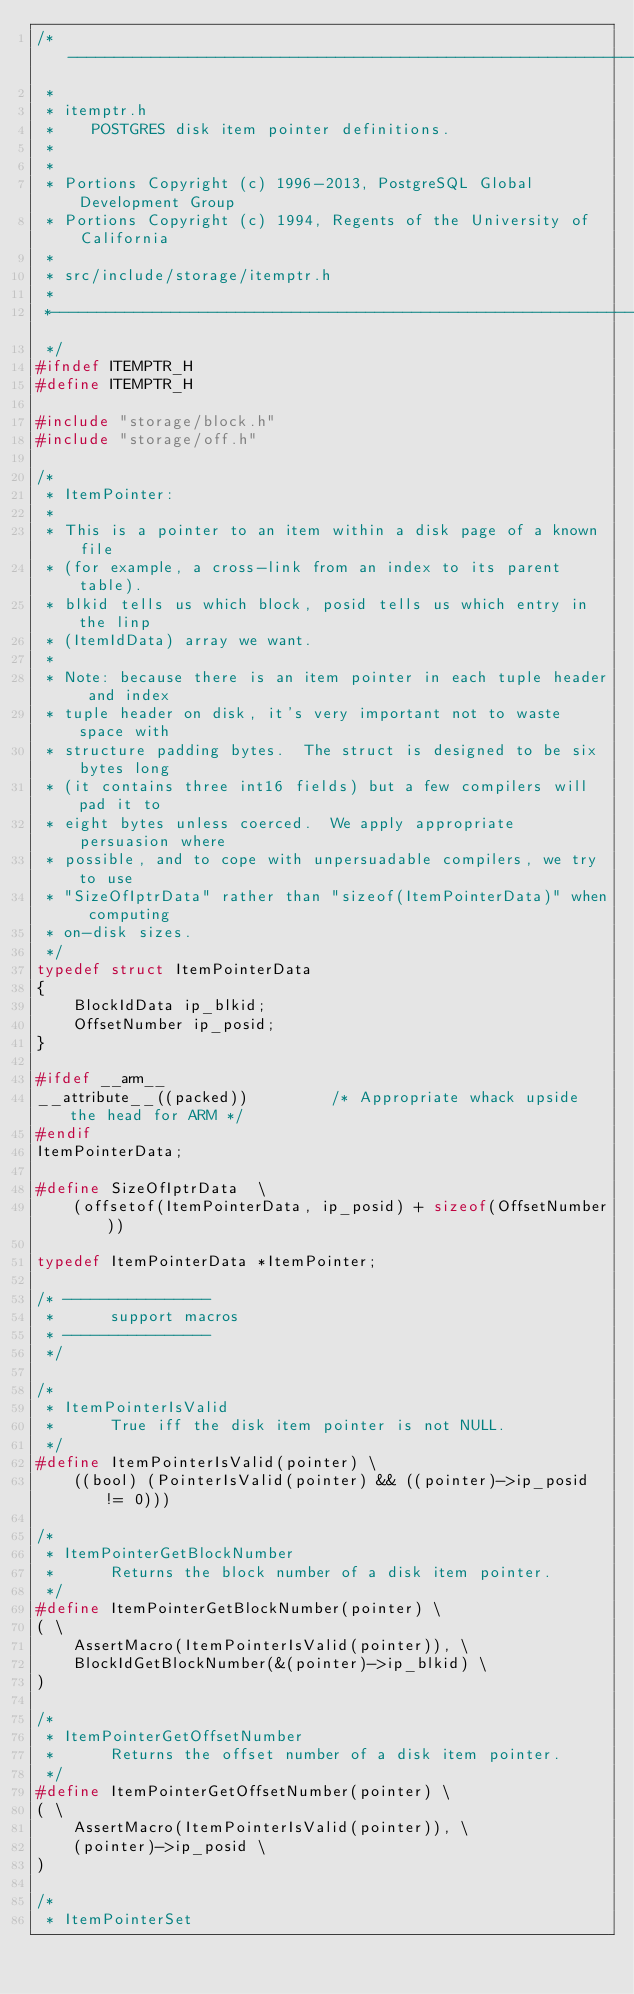<code> <loc_0><loc_0><loc_500><loc_500><_C_>/*-------------------------------------------------------------------------
 *
 * itemptr.h
 *	  POSTGRES disk item pointer definitions.
 *
 *
 * Portions Copyright (c) 1996-2013, PostgreSQL Global Development Group
 * Portions Copyright (c) 1994, Regents of the University of California
 *
 * src/include/storage/itemptr.h
 *
 *-------------------------------------------------------------------------
 */
#ifndef ITEMPTR_H
#define ITEMPTR_H

#include "storage/block.h"
#include "storage/off.h"

/*
 * ItemPointer:
 *
 * This is a pointer to an item within a disk page of a known file
 * (for example, a cross-link from an index to its parent table).
 * blkid tells us which block, posid tells us which entry in the linp
 * (ItemIdData) array we want.
 *
 * Note: because there is an item pointer in each tuple header and index
 * tuple header on disk, it's very important not to waste space with
 * structure padding bytes.  The struct is designed to be six bytes long
 * (it contains three int16 fields) but a few compilers will pad it to
 * eight bytes unless coerced.  We apply appropriate persuasion where
 * possible, and to cope with unpersuadable compilers, we try to use
 * "SizeOfIptrData" rather than "sizeof(ItemPointerData)" when computing
 * on-disk sizes.
 */
typedef struct ItemPointerData
{
	BlockIdData ip_blkid;
	OffsetNumber ip_posid;
}

#ifdef __arm__
__attribute__((packed))			/* Appropriate whack upside the head for ARM */
#endif
ItemPointerData;

#define SizeOfIptrData	\
	(offsetof(ItemPointerData, ip_posid) + sizeof(OffsetNumber))

typedef ItemPointerData *ItemPointer;

/* ----------------
 *		support macros
 * ----------------
 */

/*
 * ItemPointerIsValid
 *		True iff the disk item pointer is not NULL.
 */
#define ItemPointerIsValid(pointer) \
	((bool) (PointerIsValid(pointer) && ((pointer)->ip_posid != 0)))

/*
 * ItemPointerGetBlockNumber
 *		Returns the block number of a disk item pointer.
 */
#define ItemPointerGetBlockNumber(pointer) \
( \
	AssertMacro(ItemPointerIsValid(pointer)), \
	BlockIdGetBlockNumber(&(pointer)->ip_blkid) \
)

/*
 * ItemPointerGetOffsetNumber
 *		Returns the offset number of a disk item pointer.
 */
#define ItemPointerGetOffsetNumber(pointer) \
( \
	AssertMacro(ItemPointerIsValid(pointer)), \
	(pointer)->ip_posid \
)

/*
 * ItemPointerSet</code> 